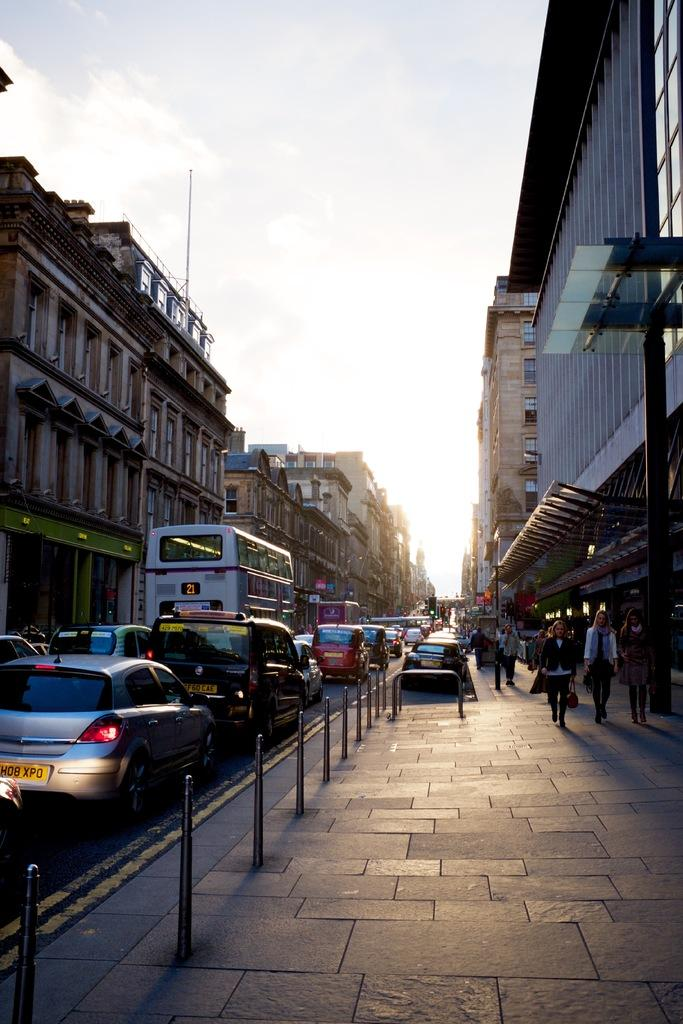<image>
Provide a brief description of the given image. a bus with the number 21 on the back of it 